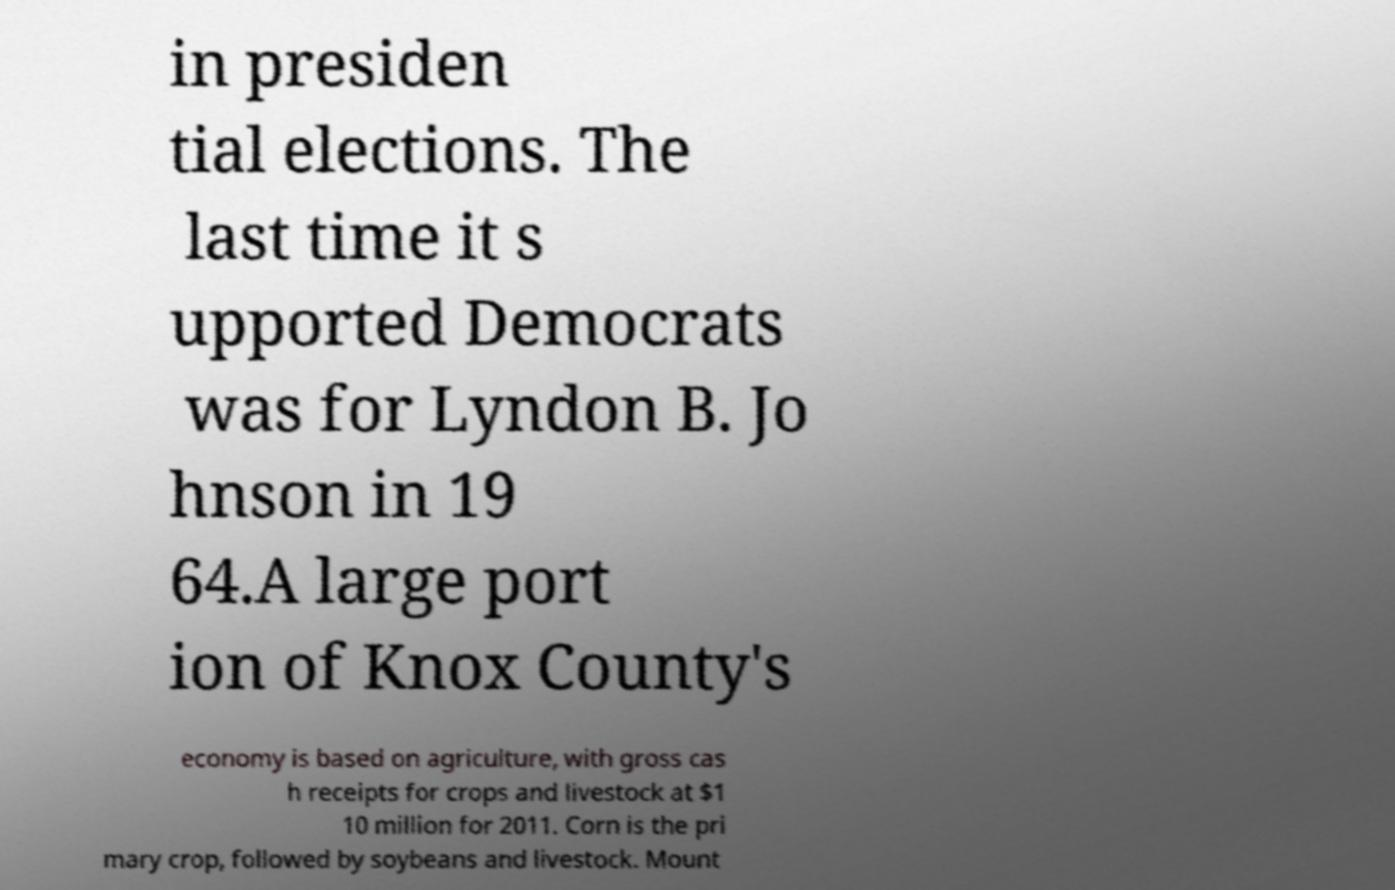Please read and relay the text visible in this image. What does it say? in presiden tial elections. The last time it s upported Democrats was for Lyndon B. Jo hnson in 19 64.A large port ion of Knox County's economy is based on agriculture, with gross cas h receipts for crops and livestock at $1 10 million for 2011. Corn is the pri mary crop, followed by soybeans and livestock. Mount 